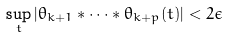Convert formula to latex. <formula><loc_0><loc_0><loc_500><loc_500>\sup _ { t } | \theta _ { k + 1 } * \cdots * \theta _ { k + p } ( t ) | < 2 \epsilon</formula> 